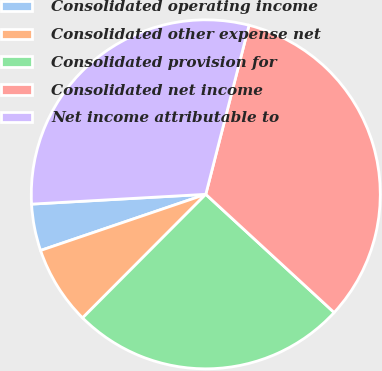Convert chart. <chart><loc_0><loc_0><loc_500><loc_500><pie_chart><fcel>Consolidated operating income<fcel>Consolidated other expense net<fcel>Consolidated provision for<fcel>Consolidated net income<fcel>Net income attributable to<nl><fcel>4.32%<fcel>7.31%<fcel>25.63%<fcel>32.86%<fcel>29.88%<nl></chart> 